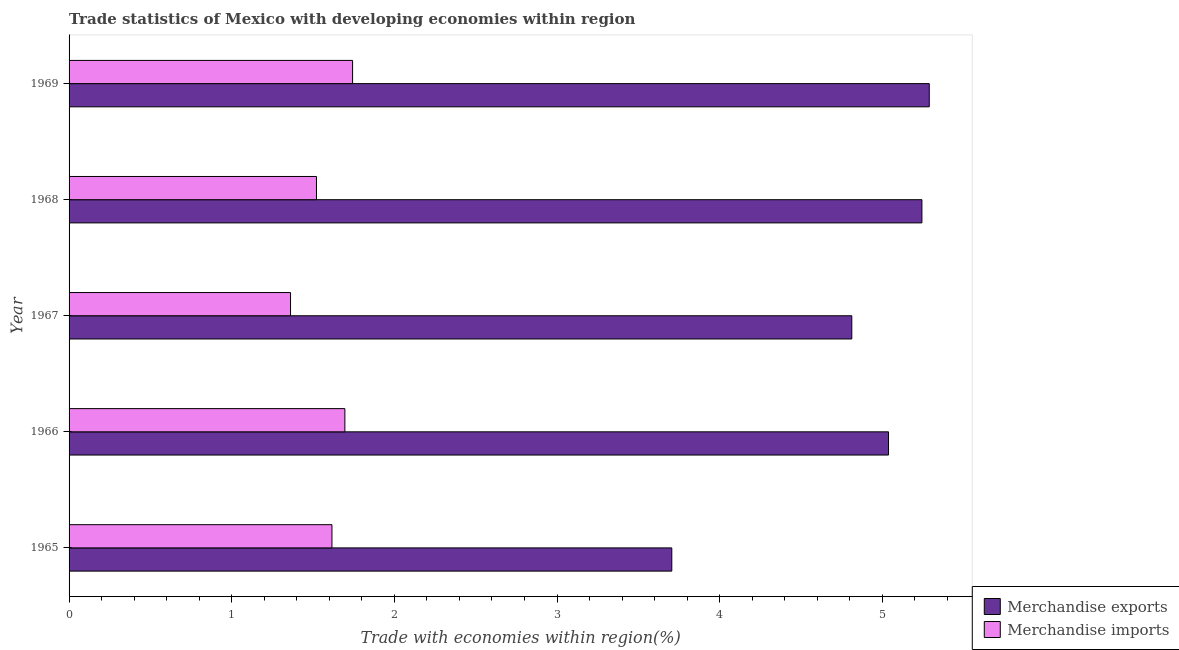How many groups of bars are there?
Your response must be concise. 5. Are the number of bars on each tick of the Y-axis equal?
Ensure brevity in your answer.  Yes. How many bars are there on the 5th tick from the top?
Offer a very short reply. 2. What is the label of the 2nd group of bars from the top?
Provide a short and direct response. 1968. In how many cases, is the number of bars for a given year not equal to the number of legend labels?
Provide a succinct answer. 0. What is the merchandise exports in 1968?
Make the answer very short. 5.24. Across all years, what is the maximum merchandise imports?
Offer a very short reply. 1.74. Across all years, what is the minimum merchandise imports?
Offer a very short reply. 1.36. In which year was the merchandise imports maximum?
Provide a succinct answer. 1969. In which year was the merchandise exports minimum?
Give a very brief answer. 1965. What is the total merchandise imports in the graph?
Your response must be concise. 7.94. What is the difference between the merchandise exports in 1966 and that in 1967?
Offer a very short reply. 0.23. What is the difference between the merchandise exports in 1967 and the merchandise imports in 1965?
Ensure brevity in your answer.  3.2. What is the average merchandise exports per year?
Offer a very short reply. 4.82. In the year 1965, what is the difference between the merchandise exports and merchandise imports?
Your answer should be very brief. 2.09. What is the ratio of the merchandise imports in 1968 to that in 1969?
Provide a short and direct response. 0.87. Is the difference between the merchandise exports in 1966 and 1967 greater than the difference between the merchandise imports in 1966 and 1967?
Make the answer very short. No. What is the difference between the highest and the second highest merchandise imports?
Provide a short and direct response. 0.05. What is the difference between the highest and the lowest merchandise imports?
Your answer should be very brief. 0.38. What does the 1st bar from the top in 1965 represents?
Make the answer very short. Merchandise imports. What does the 2nd bar from the bottom in 1965 represents?
Your answer should be very brief. Merchandise imports. Are all the bars in the graph horizontal?
Your answer should be very brief. Yes. How many years are there in the graph?
Keep it short and to the point. 5. What is the difference between two consecutive major ticks on the X-axis?
Give a very brief answer. 1. Are the values on the major ticks of X-axis written in scientific E-notation?
Keep it short and to the point. No. Where does the legend appear in the graph?
Provide a succinct answer. Bottom right. How are the legend labels stacked?
Provide a succinct answer. Vertical. What is the title of the graph?
Your answer should be very brief. Trade statistics of Mexico with developing economies within region. What is the label or title of the X-axis?
Offer a very short reply. Trade with economies within region(%). What is the label or title of the Y-axis?
Provide a succinct answer. Year. What is the Trade with economies within region(%) in Merchandise exports in 1965?
Give a very brief answer. 3.71. What is the Trade with economies within region(%) in Merchandise imports in 1965?
Your answer should be very brief. 1.62. What is the Trade with economies within region(%) of Merchandise exports in 1966?
Give a very brief answer. 5.04. What is the Trade with economies within region(%) of Merchandise imports in 1966?
Provide a succinct answer. 1.7. What is the Trade with economies within region(%) of Merchandise exports in 1967?
Provide a succinct answer. 4.81. What is the Trade with economies within region(%) of Merchandise imports in 1967?
Your answer should be very brief. 1.36. What is the Trade with economies within region(%) of Merchandise exports in 1968?
Your answer should be very brief. 5.24. What is the Trade with economies within region(%) of Merchandise imports in 1968?
Your answer should be compact. 1.52. What is the Trade with economies within region(%) in Merchandise exports in 1969?
Offer a terse response. 5.29. What is the Trade with economies within region(%) in Merchandise imports in 1969?
Keep it short and to the point. 1.74. Across all years, what is the maximum Trade with economies within region(%) of Merchandise exports?
Provide a succinct answer. 5.29. Across all years, what is the maximum Trade with economies within region(%) in Merchandise imports?
Provide a succinct answer. 1.74. Across all years, what is the minimum Trade with economies within region(%) in Merchandise exports?
Offer a terse response. 3.71. Across all years, what is the minimum Trade with economies within region(%) in Merchandise imports?
Your answer should be compact. 1.36. What is the total Trade with economies within region(%) in Merchandise exports in the graph?
Offer a terse response. 24.09. What is the total Trade with economies within region(%) of Merchandise imports in the graph?
Ensure brevity in your answer.  7.94. What is the difference between the Trade with economies within region(%) of Merchandise exports in 1965 and that in 1966?
Offer a very short reply. -1.33. What is the difference between the Trade with economies within region(%) of Merchandise imports in 1965 and that in 1966?
Make the answer very short. -0.08. What is the difference between the Trade with economies within region(%) in Merchandise exports in 1965 and that in 1967?
Make the answer very short. -1.11. What is the difference between the Trade with economies within region(%) in Merchandise imports in 1965 and that in 1967?
Make the answer very short. 0.25. What is the difference between the Trade with economies within region(%) of Merchandise exports in 1965 and that in 1968?
Keep it short and to the point. -1.54. What is the difference between the Trade with economies within region(%) in Merchandise imports in 1965 and that in 1968?
Provide a short and direct response. 0.1. What is the difference between the Trade with economies within region(%) in Merchandise exports in 1965 and that in 1969?
Your answer should be compact. -1.58. What is the difference between the Trade with economies within region(%) of Merchandise imports in 1965 and that in 1969?
Provide a short and direct response. -0.13. What is the difference between the Trade with economies within region(%) of Merchandise exports in 1966 and that in 1967?
Provide a succinct answer. 0.23. What is the difference between the Trade with economies within region(%) in Merchandise imports in 1966 and that in 1967?
Keep it short and to the point. 0.33. What is the difference between the Trade with economies within region(%) of Merchandise exports in 1966 and that in 1968?
Your response must be concise. -0.21. What is the difference between the Trade with economies within region(%) in Merchandise imports in 1966 and that in 1968?
Your answer should be compact. 0.17. What is the difference between the Trade with economies within region(%) in Merchandise exports in 1966 and that in 1969?
Provide a short and direct response. -0.25. What is the difference between the Trade with economies within region(%) in Merchandise imports in 1966 and that in 1969?
Provide a succinct answer. -0.05. What is the difference between the Trade with economies within region(%) in Merchandise exports in 1967 and that in 1968?
Keep it short and to the point. -0.43. What is the difference between the Trade with economies within region(%) in Merchandise imports in 1967 and that in 1968?
Provide a succinct answer. -0.16. What is the difference between the Trade with economies within region(%) in Merchandise exports in 1967 and that in 1969?
Make the answer very short. -0.48. What is the difference between the Trade with economies within region(%) of Merchandise imports in 1967 and that in 1969?
Offer a very short reply. -0.38. What is the difference between the Trade with economies within region(%) of Merchandise exports in 1968 and that in 1969?
Your answer should be very brief. -0.05. What is the difference between the Trade with economies within region(%) in Merchandise imports in 1968 and that in 1969?
Ensure brevity in your answer.  -0.22. What is the difference between the Trade with economies within region(%) of Merchandise exports in 1965 and the Trade with economies within region(%) of Merchandise imports in 1966?
Provide a short and direct response. 2.01. What is the difference between the Trade with economies within region(%) of Merchandise exports in 1965 and the Trade with economies within region(%) of Merchandise imports in 1967?
Ensure brevity in your answer.  2.34. What is the difference between the Trade with economies within region(%) in Merchandise exports in 1965 and the Trade with economies within region(%) in Merchandise imports in 1968?
Offer a terse response. 2.18. What is the difference between the Trade with economies within region(%) in Merchandise exports in 1965 and the Trade with economies within region(%) in Merchandise imports in 1969?
Make the answer very short. 1.96. What is the difference between the Trade with economies within region(%) of Merchandise exports in 1966 and the Trade with economies within region(%) of Merchandise imports in 1967?
Make the answer very short. 3.68. What is the difference between the Trade with economies within region(%) in Merchandise exports in 1966 and the Trade with economies within region(%) in Merchandise imports in 1968?
Ensure brevity in your answer.  3.52. What is the difference between the Trade with economies within region(%) of Merchandise exports in 1966 and the Trade with economies within region(%) of Merchandise imports in 1969?
Your response must be concise. 3.29. What is the difference between the Trade with economies within region(%) in Merchandise exports in 1967 and the Trade with economies within region(%) in Merchandise imports in 1968?
Provide a succinct answer. 3.29. What is the difference between the Trade with economies within region(%) of Merchandise exports in 1967 and the Trade with economies within region(%) of Merchandise imports in 1969?
Ensure brevity in your answer.  3.07. What is the difference between the Trade with economies within region(%) of Merchandise exports in 1968 and the Trade with economies within region(%) of Merchandise imports in 1969?
Offer a terse response. 3.5. What is the average Trade with economies within region(%) of Merchandise exports per year?
Provide a short and direct response. 4.82. What is the average Trade with economies within region(%) in Merchandise imports per year?
Provide a short and direct response. 1.59. In the year 1965, what is the difference between the Trade with economies within region(%) of Merchandise exports and Trade with economies within region(%) of Merchandise imports?
Offer a terse response. 2.09. In the year 1966, what is the difference between the Trade with economies within region(%) of Merchandise exports and Trade with economies within region(%) of Merchandise imports?
Provide a short and direct response. 3.34. In the year 1967, what is the difference between the Trade with economies within region(%) of Merchandise exports and Trade with economies within region(%) of Merchandise imports?
Your answer should be compact. 3.45. In the year 1968, what is the difference between the Trade with economies within region(%) of Merchandise exports and Trade with economies within region(%) of Merchandise imports?
Ensure brevity in your answer.  3.72. In the year 1969, what is the difference between the Trade with economies within region(%) of Merchandise exports and Trade with economies within region(%) of Merchandise imports?
Offer a very short reply. 3.55. What is the ratio of the Trade with economies within region(%) of Merchandise exports in 1965 to that in 1966?
Provide a short and direct response. 0.74. What is the ratio of the Trade with economies within region(%) of Merchandise imports in 1965 to that in 1966?
Ensure brevity in your answer.  0.95. What is the ratio of the Trade with economies within region(%) of Merchandise exports in 1965 to that in 1967?
Make the answer very short. 0.77. What is the ratio of the Trade with economies within region(%) of Merchandise imports in 1965 to that in 1967?
Your answer should be compact. 1.19. What is the ratio of the Trade with economies within region(%) in Merchandise exports in 1965 to that in 1968?
Offer a very short reply. 0.71. What is the ratio of the Trade with economies within region(%) in Merchandise imports in 1965 to that in 1968?
Ensure brevity in your answer.  1.06. What is the ratio of the Trade with economies within region(%) of Merchandise exports in 1965 to that in 1969?
Your answer should be compact. 0.7. What is the ratio of the Trade with economies within region(%) of Merchandise imports in 1965 to that in 1969?
Your answer should be compact. 0.93. What is the ratio of the Trade with economies within region(%) in Merchandise exports in 1966 to that in 1967?
Your answer should be very brief. 1.05. What is the ratio of the Trade with economies within region(%) of Merchandise imports in 1966 to that in 1967?
Provide a succinct answer. 1.25. What is the ratio of the Trade with economies within region(%) of Merchandise exports in 1966 to that in 1968?
Ensure brevity in your answer.  0.96. What is the ratio of the Trade with economies within region(%) of Merchandise imports in 1966 to that in 1968?
Ensure brevity in your answer.  1.11. What is the ratio of the Trade with economies within region(%) in Merchandise exports in 1966 to that in 1969?
Keep it short and to the point. 0.95. What is the ratio of the Trade with economies within region(%) of Merchandise imports in 1966 to that in 1969?
Offer a very short reply. 0.97. What is the ratio of the Trade with economies within region(%) in Merchandise exports in 1967 to that in 1968?
Your answer should be very brief. 0.92. What is the ratio of the Trade with economies within region(%) in Merchandise imports in 1967 to that in 1968?
Provide a succinct answer. 0.9. What is the ratio of the Trade with economies within region(%) in Merchandise exports in 1967 to that in 1969?
Your answer should be compact. 0.91. What is the ratio of the Trade with economies within region(%) of Merchandise imports in 1967 to that in 1969?
Keep it short and to the point. 0.78. What is the ratio of the Trade with economies within region(%) of Merchandise exports in 1968 to that in 1969?
Your response must be concise. 0.99. What is the ratio of the Trade with economies within region(%) of Merchandise imports in 1968 to that in 1969?
Offer a very short reply. 0.87. What is the difference between the highest and the second highest Trade with economies within region(%) of Merchandise exports?
Keep it short and to the point. 0.05. What is the difference between the highest and the second highest Trade with economies within region(%) in Merchandise imports?
Ensure brevity in your answer.  0.05. What is the difference between the highest and the lowest Trade with economies within region(%) in Merchandise exports?
Your response must be concise. 1.58. What is the difference between the highest and the lowest Trade with economies within region(%) of Merchandise imports?
Your answer should be compact. 0.38. 